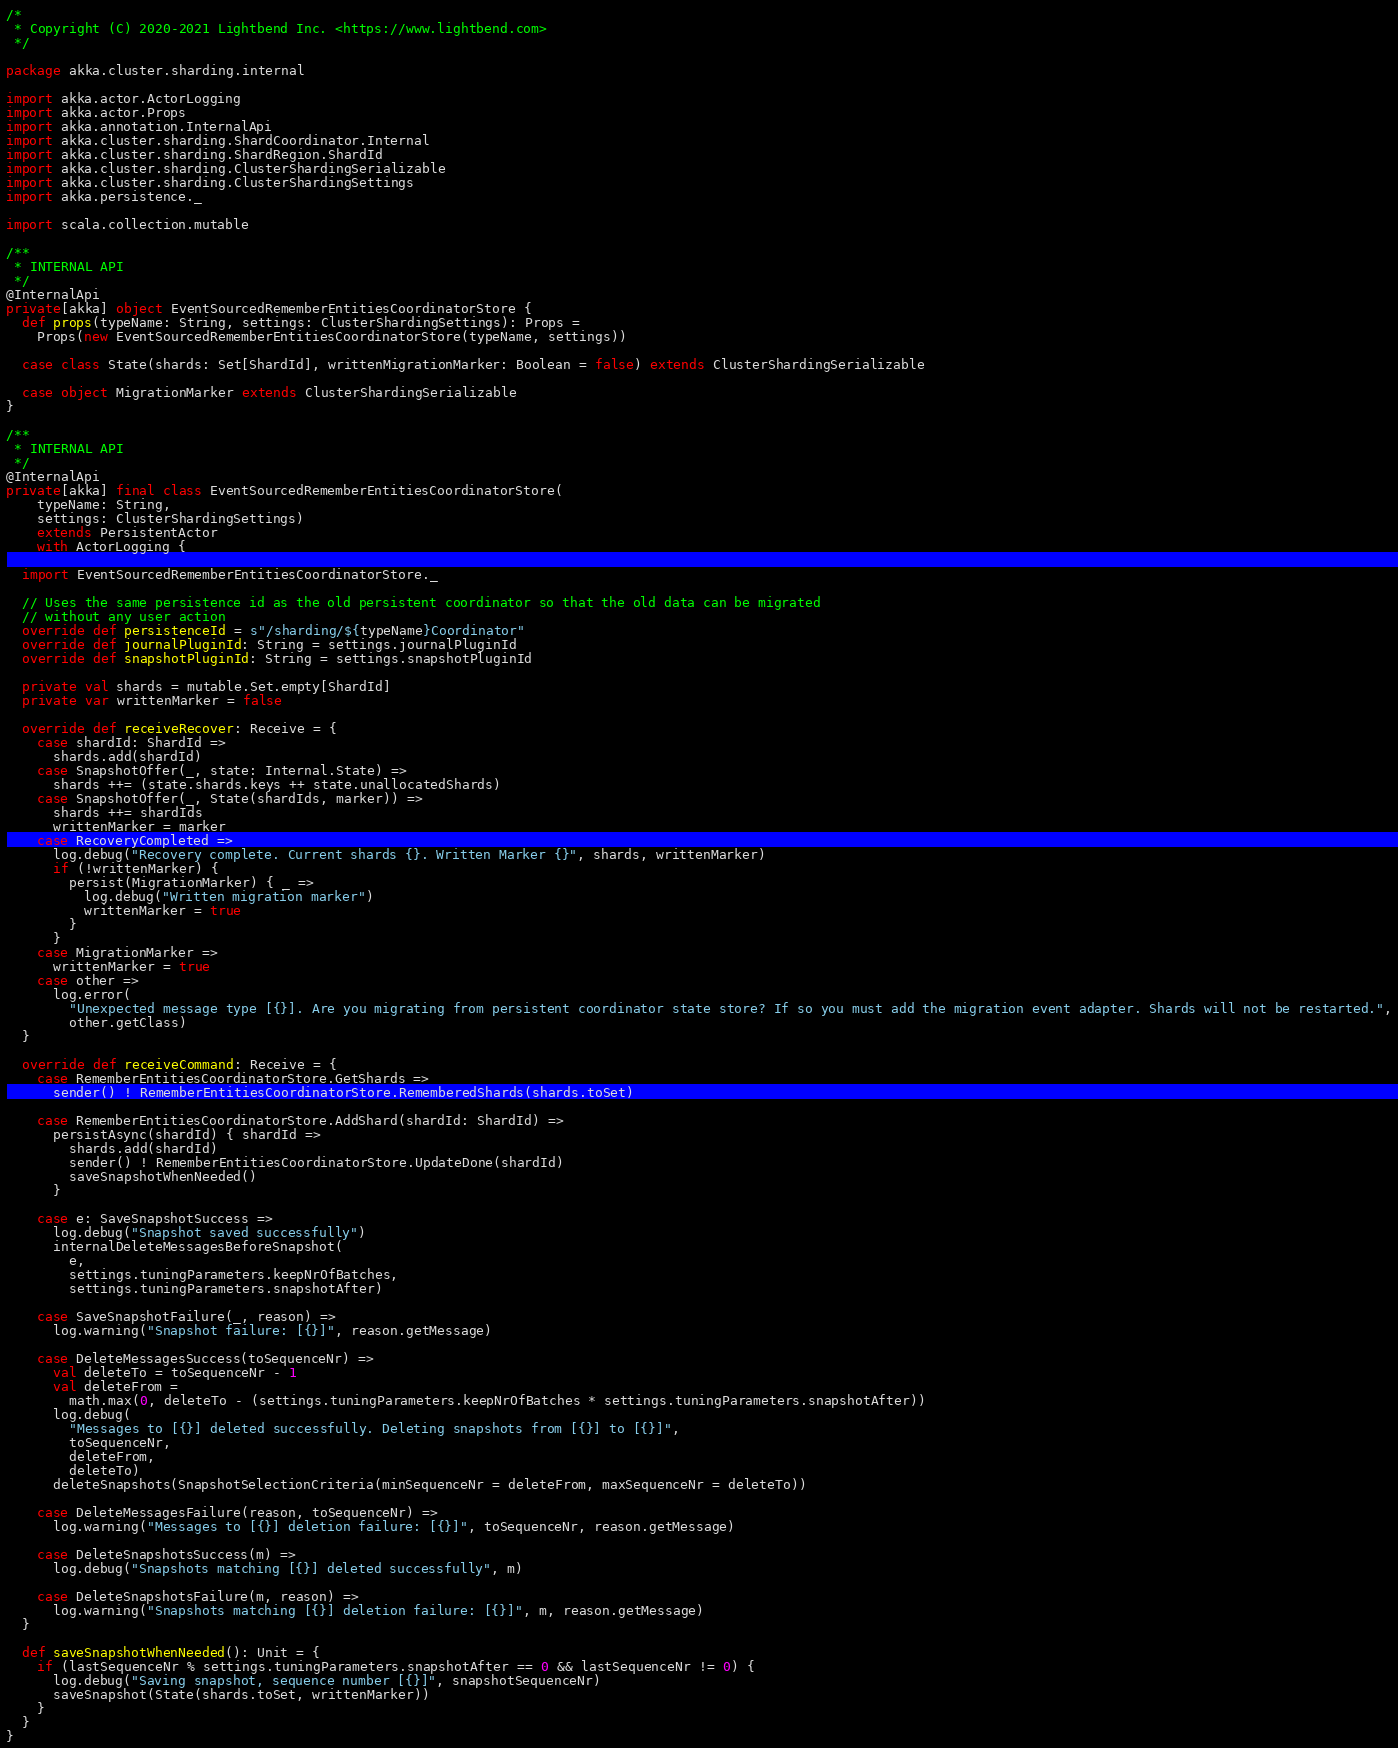Convert code to text. <code><loc_0><loc_0><loc_500><loc_500><_Scala_>/*
 * Copyright (C) 2020-2021 Lightbend Inc. <https://www.lightbend.com>
 */

package akka.cluster.sharding.internal

import akka.actor.ActorLogging
import akka.actor.Props
import akka.annotation.InternalApi
import akka.cluster.sharding.ShardCoordinator.Internal
import akka.cluster.sharding.ShardRegion.ShardId
import akka.cluster.sharding.ClusterShardingSerializable
import akka.cluster.sharding.ClusterShardingSettings
import akka.persistence._

import scala.collection.mutable

/**
 * INTERNAL API
 */
@InternalApi
private[akka] object EventSourcedRememberEntitiesCoordinatorStore {
  def props(typeName: String, settings: ClusterShardingSettings): Props =
    Props(new EventSourcedRememberEntitiesCoordinatorStore(typeName, settings))

  case class State(shards: Set[ShardId], writtenMigrationMarker: Boolean = false) extends ClusterShardingSerializable

  case object MigrationMarker extends ClusterShardingSerializable
}

/**
 * INTERNAL API
 */
@InternalApi
private[akka] final class EventSourcedRememberEntitiesCoordinatorStore(
    typeName: String,
    settings: ClusterShardingSettings)
    extends PersistentActor
    with ActorLogging {

  import EventSourcedRememberEntitiesCoordinatorStore._

  // Uses the same persistence id as the old persistent coordinator so that the old data can be migrated
  // without any user action
  override def persistenceId = s"/sharding/${typeName}Coordinator"
  override def journalPluginId: String = settings.journalPluginId
  override def snapshotPluginId: String = settings.snapshotPluginId

  private val shards = mutable.Set.empty[ShardId]
  private var writtenMarker = false

  override def receiveRecover: Receive = {
    case shardId: ShardId =>
      shards.add(shardId)
    case SnapshotOffer(_, state: Internal.State) =>
      shards ++= (state.shards.keys ++ state.unallocatedShards)
    case SnapshotOffer(_, State(shardIds, marker)) =>
      shards ++= shardIds
      writtenMarker = marker
    case RecoveryCompleted =>
      log.debug("Recovery complete. Current shards {}. Written Marker {}", shards, writtenMarker)
      if (!writtenMarker) {
        persist(MigrationMarker) { _ =>
          log.debug("Written migration marker")
          writtenMarker = true
        }
      }
    case MigrationMarker =>
      writtenMarker = true
    case other =>
      log.error(
        "Unexpected message type [{}]. Are you migrating from persistent coordinator state store? If so you must add the migration event adapter. Shards will not be restarted.",
        other.getClass)
  }

  override def receiveCommand: Receive = {
    case RememberEntitiesCoordinatorStore.GetShards =>
      sender() ! RememberEntitiesCoordinatorStore.RememberedShards(shards.toSet)

    case RememberEntitiesCoordinatorStore.AddShard(shardId: ShardId) =>
      persistAsync(shardId) { shardId =>
        shards.add(shardId)
        sender() ! RememberEntitiesCoordinatorStore.UpdateDone(shardId)
        saveSnapshotWhenNeeded()
      }

    case e: SaveSnapshotSuccess =>
      log.debug("Snapshot saved successfully")
      internalDeleteMessagesBeforeSnapshot(
        e,
        settings.tuningParameters.keepNrOfBatches,
        settings.tuningParameters.snapshotAfter)

    case SaveSnapshotFailure(_, reason) =>
      log.warning("Snapshot failure: [{}]", reason.getMessage)

    case DeleteMessagesSuccess(toSequenceNr) =>
      val deleteTo = toSequenceNr - 1
      val deleteFrom =
        math.max(0, deleteTo - (settings.tuningParameters.keepNrOfBatches * settings.tuningParameters.snapshotAfter))
      log.debug(
        "Messages to [{}] deleted successfully. Deleting snapshots from [{}] to [{}]",
        toSequenceNr,
        deleteFrom,
        deleteTo)
      deleteSnapshots(SnapshotSelectionCriteria(minSequenceNr = deleteFrom, maxSequenceNr = deleteTo))

    case DeleteMessagesFailure(reason, toSequenceNr) =>
      log.warning("Messages to [{}] deletion failure: [{}]", toSequenceNr, reason.getMessage)

    case DeleteSnapshotsSuccess(m) =>
      log.debug("Snapshots matching [{}] deleted successfully", m)

    case DeleteSnapshotsFailure(m, reason) =>
      log.warning("Snapshots matching [{}] deletion failure: [{}]", m, reason.getMessage)
  }

  def saveSnapshotWhenNeeded(): Unit = {
    if (lastSequenceNr % settings.tuningParameters.snapshotAfter == 0 && lastSequenceNr != 0) {
      log.debug("Saving snapshot, sequence number [{}]", snapshotSequenceNr)
      saveSnapshot(State(shards.toSet, writtenMarker))
    }
  }
}
</code> 